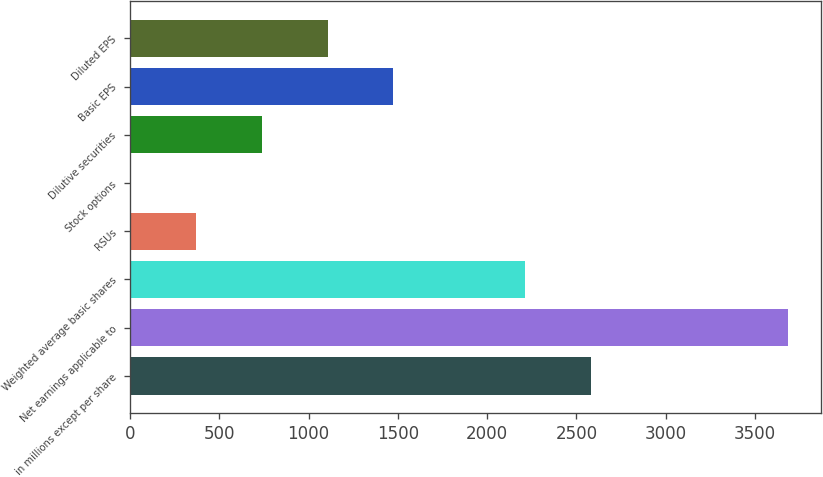Convert chart. <chart><loc_0><loc_0><loc_500><loc_500><bar_chart><fcel>in millions except per share<fcel>Net earnings applicable to<fcel>Weighted average basic shares<fcel>RSUs<fcel>Stock options<fcel>Dilutive securities<fcel>Basic EPS<fcel>Diluted EPS<nl><fcel>2580.16<fcel>3685<fcel>2211.88<fcel>370.48<fcel>2.2<fcel>738.76<fcel>1475.32<fcel>1107.04<nl></chart> 